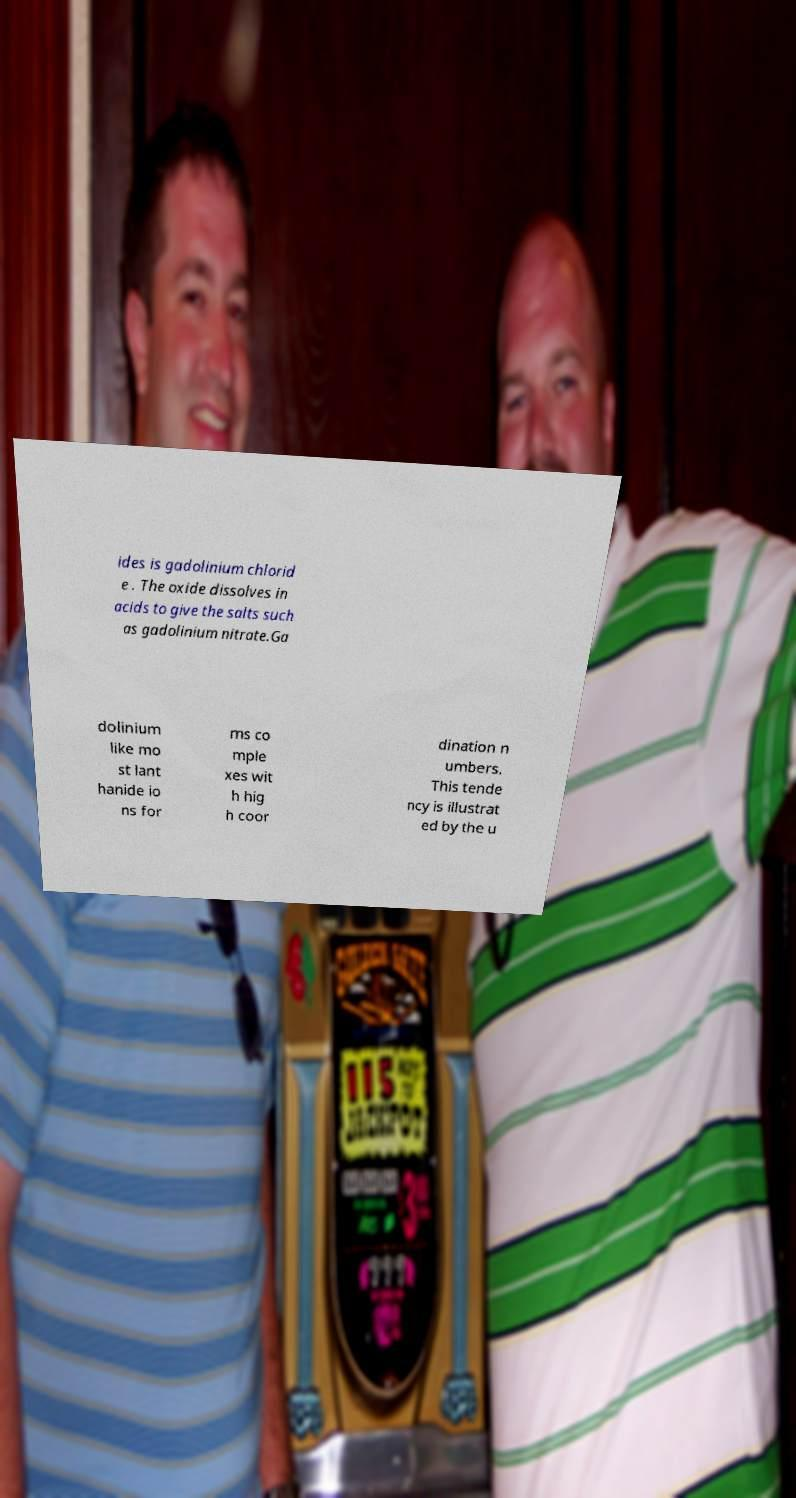Can you read and provide the text displayed in the image?This photo seems to have some interesting text. Can you extract and type it out for me? ides is gadolinium chlorid e . The oxide dissolves in acids to give the salts such as gadolinium nitrate.Ga dolinium like mo st lant hanide io ns for ms co mple xes wit h hig h coor dination n umbers. This tende ncy is illustrat ed by the u 